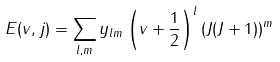Convert formula to latex. <formula><loc_0><loc_0><loc_500><loc_500>E ( v , j ) = \sum _ { l , m } y _ { l m } \left ( v + \frac { 1 } { 2 } \right ) ^ { l } \left ( J ( J + 1 ) \right ) ^ { m }</formula> 